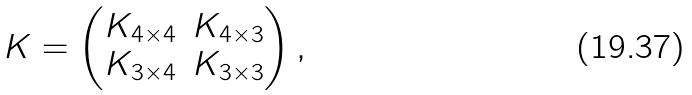<formula> <loc_0><loc_0><loc_500><loc_500>K = \begin{pmatrix} K _ { 4 \times 4 } & K _ { 4 \times 3 } \\ K _ { 3 \times 4 } & K _ { 3 \times 3 } \end{pmatrix} ,</formula> 